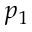<formula> <loc_0><loc_0><loc_500><loc_500>p _ { 1 }</formula> 